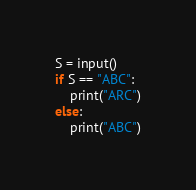Convert code to text. <code><loc_0><loc_0><loc_500><loc_500><_Python_>S = input()
if S == "ABC":
    print("ARC")
else:
    print("ABC")</code> 